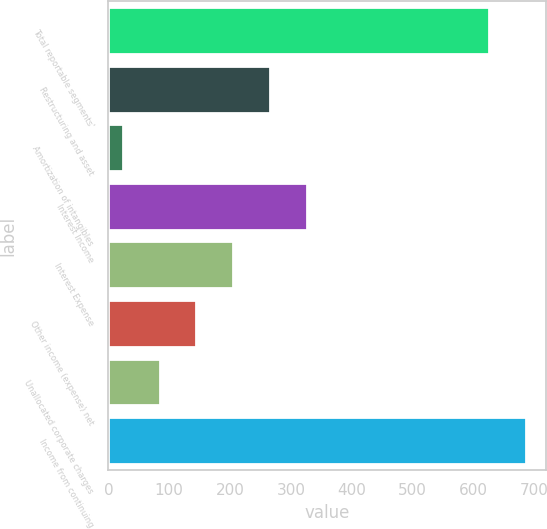Convert chart to OTSL. <chart><loc_0><loc_0><loc_500><loc_500><bar_chart><fcel>Total reportable segments'<fcel>Restructuring and asset<fcel>Amortization of intangibles<fcel>Interest Income<fcel>Interest Expense<fcel>Other income (expense) net<fcel>Unallocated corporate charges<fcel>Income from continuing<nl><fcel>625<fcel>265.2<fcel>24<fcel>325.5<fcel>204.9<fcel>144.6<fcel>84.3<fcel>685.3<nl></chart> 